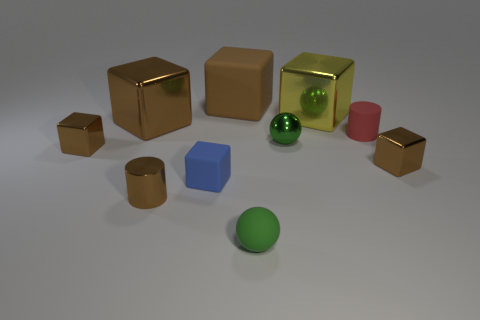Subtract all yellow balls. How many brown blocks are left? 4 Subtract 1 blocks. How many blocks are left? 5 Subtract all blue cubes. How many cubes are left? 5 Subtract all big rubber blocks. How many blocks are left? 5 Subtract all blue blocks. Subtract all brown cylinders. How many blocks are left? 5 Subtract all blocks. How many objects are left? 4 Subtract all big brown matte objects. Subtract all tiny blue balls. How many objects are left? 9 Add 9 large brown rubber things. How many large brown rubber things are left? 10 Add 6 tiny matte cylinders. How many tiny matte cylinders exist? 7 Subtract 0 red balls. How many objects are left? 10 